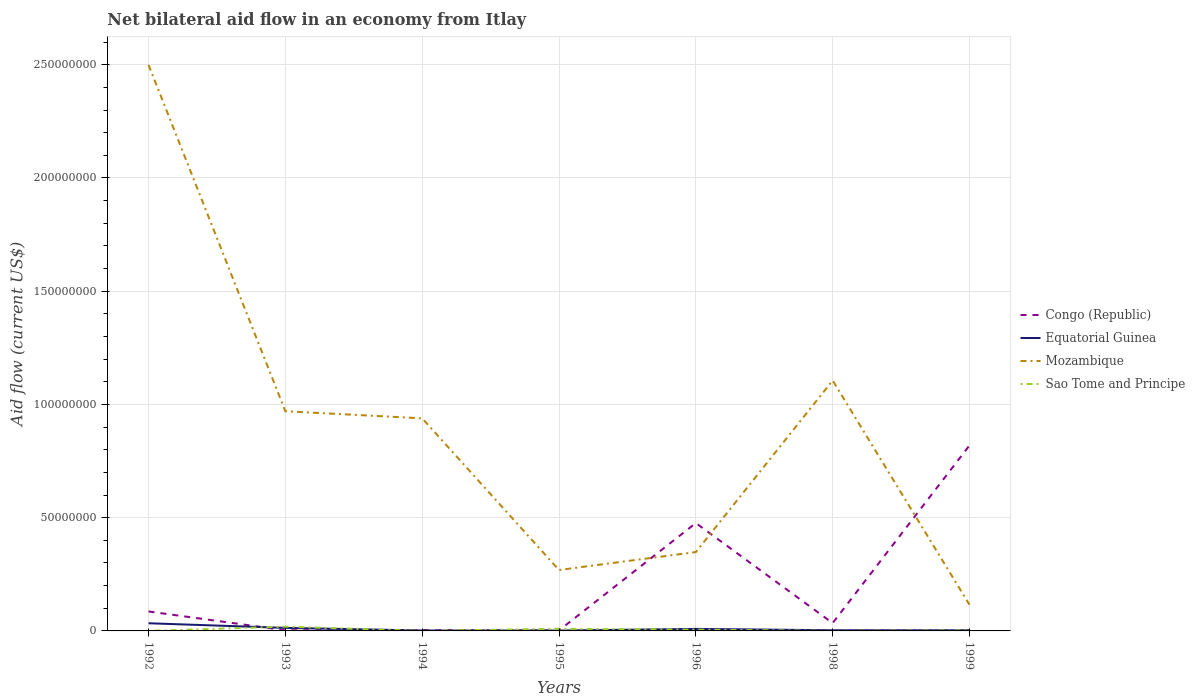Does the line corresponding to Equatorial Guinea intersect with the line corresponding to Sao Tome and Principe?
Keep it short and to the point. Yes. Is the number of lines equal to the number of legend labels?
Make the answer very short. Yes. Across all years, what is the maximum net bilateral aid flow in Mozambique?
Provide a short and direct response. 1.16e+07. What is the total net bilateral aid flow in Equatorial Guinea in the graph?
Offer a terse response. 4.50e+05. What is the difference between the highest and the second highest net bilateral aid flow in Equatorial Guinea?
Keep it short and to the point. 3.23e+06. How many lines are there?
Offer a very short reply. 4. How many years are there in the graph?
Offer a terse response. 7. What is the difference between two consecutive major ticks on the Y-axis?
Provide a succinct answer. 5.00e+07. Are the values on the major ticks of Y-axis written in scientific E-notation?
Your answer should be very brief. No. Does the graph contain any zero values?
Your answer should be compact. No. Does the graph contain grids?
Keep it short and to the point. Yes. How are the legend labels stacked?
Keep it short and to the point. Vertical. What is the title of the graph?
Give a very brief answer. Net bilateral aid flow in an economy from Itlay. Does "United Kingdom" appear as one of the legend labels in the graph?
Your response must be concise. No. What is the label or title of the X-axis?
Provide a short and direct response. Years. What is the label or title of the Y-axis?
Offer a terse response. Aid flow (current US$). What is the Aid flow (current US$) in Congo (Republic) in 1992?
Ensure brevity in your answer.  8.59e+06. What is the Aid flow (current US$) in Equatorial Guinea in 1992?
Make the answer very short. 3.39e+06. What is the Aid flow (current US$) of Mozambique in 1992?
Provide a succinct answer. 2.50e+08. What is the Aid flow (current US$) of Sao Tome and Principe in 1992?
Make the answer very short. 10000. What is the Aid flow (current US$) in Equatorial Guinea in 1993?
Your answer should be very brief. 1.34e+06. What is the Aid flow (current US$) in Mozambique in 1993?
Provide a short and direct response. 9.70e+07. What is the Aid flow (current US$) of Sao Tome and Principe in 1993?
Offer a terse response. 1.89e+06. What is the Aid flow (current US$) of Mozambique in 1994?
Give a very brief answer. 9.39e+07. What is the Aid flow (current US$) in Sao Tome and Principe in 1994?
Give a very brief answer. 10000. What is the Aid flow (current US$) of Equatorial Guinea in 1995?
Offer a terse response. 1.60e+05. What is the Aid flow (current US$) in Mozambique in 1995?
Make the answer very short. 2.69e+07. What is the Aid flow (current US$) in Sao Tome and Principe in 1995?
Offer a very short reply. 9.40e+05. What is the Aid flow (current US$) in Congo (Republic) in 1996?
Your answer should be compact. 4.76e+07. What is the Aid flow (current US$) of Equatorial Guinea in 1996?
Provide a short and direct response. 8.90e+05. What is the Aid flow (current US$) in Mozambique in 1996?
Your answer should be compact. 3.48e+07. What is the Aid flow (current US$) of Sao Tome and Principe in 1996?
Provide a short and direct response. 5.70e+05. What is the Aid flow (current US$) in Congo (Republic) in 1998?
Offer a very short reply. 3.46e+06. What is the Aid flow (current US$) of Mozambique in 1998?
Your answer should be very brief. 1.11e+08. What is the Aid flow (current US$) of Congo (Republic) in 1999?
Make the answer very short. 8.19e+07. What is the Aid flow (current US$) of Mozambique in 1999?
Your answer should be very brief. 1.16e+07. Across all years, what is the maximum Aid flow (current US$) of Congo (Republic)?
Offer a very short reply. 8.19e+07. Across all years, what is the maximum Aid flow (current US$) in Equatorial Guinea?
Your response must be concise. 3.39e+06. Across all years, what is the maximum Aid flow (current US$) in Mozambique?
Your answer should be compact. 2.50e+08. Across all years, what is the maximum Aid flow (current US$) of Sao Tome and Principe?
Give a very brief answer. 1.89e+06. Across all years, what is the minimum Aid flow (current US$) in Congo (Republic)?
Give a very brief answer. 2.30e+05. Across all years, what is the minimum Aid flow (current US$) in Equatorial Guinea?
Keep it short and to the point. 1.60e+05. Across all years, what is the minimum Aid flow (current US$) in Mozambique?
Ensure brevity in your answer.  1.16e+07. What is the total Aid flow (current US$) of Congo (Republic) in the graph?
Provide a succinct answer. 1.42e+08. What is the total Aid flow (current US$) of Equatorial Guinea in the graph?
Ensure brevity in your answer.  6.57e+06. What is the total Aid flow (current US$) of Mozambique in the graph?
Give a very brief answer. 6.25e+08. What is the total Aid flow (current US$) of Sao Tome and Principe in the graph?
Provide a short and direct response. 3.66e+06. What is the difference between the Aid flow (current US$) in Congo (Republic) in 1992 and that in 1993?
Make the answer very short. 8.31e+06. What is the difference between the Aid flow (current US$) of Equatorial Guinea in 1992 and that in 1993?
Your answer should be compact. 2.05e+06. What is the difference between the Aid flow (current US$) of Mozambique in 1992 and that in 1993?
Provide a succinct answer. 1.53e+08. What is the difference between the Aid flow (current US$) of Sao Tome and Principe in 1992 and that in 1993?
Ensure brevity in your answer.  -1.88e+06. What is the difference between the Aid flow (current US$) of Congo (Republic) in 1992 and that in 1994?
Offer a terse response. 8.26e+06. What is the difference between the Aid flow (current US$) of Equatorial Guinea in 1992 and that in 1994?
Keep it short and to the point. 3.20e+06. What is the difference between the Aid flow (current US$) in Mozambique in 1992 and that in 1994?
Your answer should be very brief. 1.56e+08. What is the difference between the Aid flow (current US$) in Congo (Republic) in 1992 and that in 1995?
Offer a very short reply. 8.36e+06. What is the difference between the Aid flow (current US$) in Equatorial Guinea in 1992 and that in 1995?
Keep it short and to the point. 3.23e+06. What is the difference between the Aid flow (current US$) of Mozambique in 1992 and that in 1995?
Give a very brief answer. 2.23e+08. What is the difference between the Aid flow (current US$) in Sao Tome and Principe in 1992 and that in 1995?
Your answer should be compact. -9.30e+05. What is the difference between the Aid flow (current US$) of Congo (Republic) in 1992 and that in 1996?
Provide a succinct answer. -3.90e+07. What is the difference between the Aid flow (current US$) of Equatorial Guinea in 1992 and that in 1996?
Provide a short and direct response. 2.50e+06. What is the difference between the Aid flow (current US$) in Mozambique in 1992 and that in 1996?
Your response must be concise. 2.15e+08. What is the difference between the Aid flow (current US$) of Sao Tome and Principe in 1992 and that in 1996?
Provide a succinct answer. -5.60e+05. What is the difference between the Aid flow (current US$) in Congo (Republic) in 1992 and that in 1998?
Offer a terse response. 5.13e+06. What is the difference between the Aid flow (current US$) of Equatorial Guinea in 1992 and that in 1998?
Your answer should be very brief. 3.09e+06. What is the difference between the Aid flow (current US$) of Mozambique in 1992 and that in 1998?
Provide a succinct answer. 1.39e+08. What is the difference between the Aid flow (current US$) in Congo (Republic) in 1992 and that in 1999?
Give a very brief answer. -7.33e+07. What is the difference between the Aid flow (current US$) in Equatorial Guinea in 1992 and that in 1999?
Offer a very short reply. 3.09e+06. What is the difference between the Aid flow (current US$) in Mozambique in 1992 and that in 1999?
Provide a short and direct response. 2.38e+08. What is the difference between the Aid flow (current US$) in Congo (Republic) in 1993 and that in 1994?
Provide a short and direct response. -5.00e+04. What is the difference between the Aid flow (current US$) of Equatorial Guinea in 1993 and that in 1994?
Offer a terse response. 1.15e+06. What is the difference between the Aid flow (current US$) of Mozambique in 1993 and that in 1994?
Keep it short and to the point. 3.13e+06. What is the difference between the Aid flow (current US$) of Sao Tome and Principe in 1993 and that in 1994?
Keep it short and to the point. 1.88e+06. What is the difference between the Aid flow (current US$) of Congo (Republic) in 1993 and that in 1995?
Provide a short and direct response. 5.00e+04. What is the difference between the Aid flow (current US$) in Equatorial Guinea in 1993 and that in 1995?
Offer a terse response. 1.18e+06. What is the difference between the Aid flow (current US$) in Mozambique in 1993 and that in 1995?
Keep it short and to the point. 7.01e+07. What is the difference between the Aid flow (current US$) in Sao Tome and Principe in 1993 and that in 1995?
Offer a terse response. 9.50e+05. What is the difference between the Aid flow (current US$) in Congo (Republic) in 1993 and that in 1996?
Make the answer very short. -4.74e+07. What is the difference between the Aid flow (current US$) of Equatorial Guinea in 1993 and that in 1996?
Ensure brevity in your answer.  4.50e+05. What is the difference between the Aid flow (current US$) of Mozambique in 1993 and that in 1996?
Your answer should be compact. 6.22e+07. What is the difference between the Aid flow (current US$) of Sao Tome and Principe in 1993 and that in 1996?
Provide a succinct answer. 1.32e+06. What is the difference between the Aid flow (current US$) of Congo (Republic) in 1993 and that in 1998?
Offer a terse response. -3.18e+06. What is the difference between the Aid flow (current US$) in Equatorial Guinea in 1993 and that in 1998?
Your response must be concise. 1.04e+06. What is the difference between the Aid flow (current US$) of Mozambique in 1993 and that in 1998?
Make the answer very short. -1.36e+07. What is the difference between the Aid flow (current US$) in Sao Tome and Principe in 1993 and that in 1998?
Offer a terse response. 1.87e+06. What is the difference between the Aid flow (current US$) in Congo (Republic) in 1993 and that in 1999?
Give a very brief answer. -8.16e+07. What is the difference between the Aid flow (current US$) of Equatorial Guinea in 1993 and that in 1999?
Your answer should be very brief. 1.04e+06. What is the difference between the Aid flow (current US$) of Mozambique in 1993 and that in 1999?
Offer a terse response. 8.54e+07. What is the difference between the Aid flow (current US$) of Sao Tome and Principe in 1993 and that in 1999?
Give a very brief answer. 1.67e+06. What is the difference between the Aid flow (current US$) of Congo (Republic) in 1994 and that in 1995?
Ensure brevity in your answer.  1.00e+05. What is the difference between the Aid flow (current US$) of Equatorial Guinea in 1994 and that in 1995?
Keep it short and to the point. 3.00e+04. What is the difference between the Aid flow (current US$) in Mozambique in 1994 and that in 1995?
Make the answer very short. 6.70e+07. What is the difference between the Aid flow (current US$) of Sao Tome and Principe in 1994 and that in 1995?
Your response must be concise. -9.30e+05. What is the difference between the Aid flow (current US$) of Congo (Republic) in 1994 and that in 1996?
Keep it short and to the point. -4.73e+07. What is the difference between the Aid flow (current US$) of Equatorial Guinea in 1994 and that in 1996?
Offer a terse response. -7.00e+05. What is the difference between the Aid flow (current US$) in Mozambique in 1994 and that in 1996?
Give a very brief answer. 5.91e+07. What is the difference between the Aid flow (current US$) of Sao Tome and Principe in 1994 and that in 1996?
Offer a terse response. -5.60e+05. What is the difference between the Aid flow (current US$) in Congo (Republic) in 1994 and that in 1998?
Offer a very short reply. -3.13e+06. What is the difference between the Aid flow (current US$) in Equatorial Guinea in 1994 and that in 1998?
Keep it short and to the point. -1.10e+05. What is the difference between the Aid flow (current US$) in Mozambique in 1994 and that in 1998?
Offer a very short reply. -1.67e+07. What is the difference between the Aid flow (current US$) of Sao Tome and Principe in 1994 and that in 1998?
Provide a succinct answer. -10000. What is the difference between the Aid flow (current US$) of Congo (Republic) in 1994 and that in 1999?
Give a very brief answer. -8.16e+07. What is the difference between the Aid flow (current US$) of Mozambique in 1994 and that in 1999?
Offer a very short reply. 8.23e+07. What is the difference between the Aid flow (current US$) of Congo (Republic) in 1995 and that in 1996?
Make the answer very short. -4.74e+07. What is the difference between the Aid flow (current US$) of Equatorial Guinea in 1995 and that in 1996?
Give a very brief answer. -7.30e+05. What is the difference between the Aid flow (current US$) in Mozambique in 1995 and that in 1996?
Make the answer very short. -7.91e+06. What is the difference between the Aid flow (current US$) of Congo (Republic) in 1995 and that in 1998?
Give a very brief answer. -3.23e+06. What is the difference between the Aid flow (current US$) in Mozambique in 1995 and that in 1998?
Provide a succinct answer. -8.37e+07. What is the difference between the Aid flow (current US$) of Sao Tome and Principe in 1995 and that in 1998?
Provide a short and direct response. 9.20e+05. What is the difference between the Aid flow (current US$) in Congo (Republic) in 1995 and that in 1999?
Provide a short and direct response. -8.17e+07. What is the difference between the Aid flow (current US$) in Mozambique in 1995 and that in 1999?
Keep it short and to the point. 1.53e+07. What is the difference between the Aid flow (current US$) of Sao Tome and Principe in 1995 and that in 1999?
Your answer should be very brief. 7.20e+05. What is the difference between the Aid flow (current US$) of Congo (Republic) in 1996 and that in 1998?
Your answer should be compact. 4.42e+07. What is the difference between the Aid flow (current US$) of Equatorial Guinea in 1996 and that in 1998?
Keep it short and to the point. 5.90e+05. What is the difference between the Aid flow (current US$) of Mozambique in 1996 and that in 1998?
Your answer should be very brief. -7.58e+07. What is the difference between the Aid flow (current US$) in Sao Tome and Principe in 1996 and that in 1998?
Offer a very short reply. 5.50e+05. What is the difference between the Aid flow (current US$) of Congo (Republic) in 1996 and that in 1999?
Provide a short and direct response. -3.43e+07. What is the difference between the Aid flow (current US$) in Equatorial Guinea in 1996 and that in 1999?
Keep it short and to the point. 5.90e+05. What is the difference between the Aid flow (current US$) in Mozambique in 1996 and that in 1999?
Offer a terse response. 2.32e+07. What is the difference between the Aid flow (current US$) of Sao Tome and Principe in 1996 and that in 1999?
Make the answer very short. 3.50e+05. What is the difference between the Aid flow (current US$) of Congo (Republic) in 1998 and that in 1999?
Offer a terse response. -7.84e+07. What is the difference between the Aid flow (current US$) in Equatorial Guinea in 1998 and that in 1999?
Your answer should be very brief. 0. What is the difference between the Aid flow (current US$) in Mozambique in 1998 and that in 1999?
Provide a succinct answer. 9.90e+07. What is the difference between the Aid flow (current US$) in Congo (Republic) in 1992 and the Aid flow (current US$) in Equatorial Guinea in 1993?
Provide a succinct answer. 7.25e+06. What is the difference between the Aid flow (current US$) of Congo (Republic) in 1992 and the Aid flow (current US$) of Mozambique in 1993?
Ensure brevity in your answer.  -8.84e+07. What is the difference between the Aid flow (current US$) of Congo (Republic) in 1992 and the Aid flow (current US$) of Sao Tome and Principe in 1993?
Provide a succinct answer. 6.70e+06. What is the difference between the Aid flow (current US$) in Equatorial Guinea in 1992 and the Aid flow (current US$) in Mozambique in 1993?
Your answer should be compact. -9.36e+07. What is the difference between the Aid flow (current US$) in Equatorial Guinea in 1992 and the Aid flow (current US$) in Sao Tome and Principe in 1993?
Your answer should be very brief. 1.50e+06. What is the difference between the Aid flow (current US$) of Mozambique in 1992 and the Aid flow (current US$) of Sao Tome and Principe in 1993?
Offer a very short reply. 2.48e+08. What is the difference between the Aid flow (current US$) of Congo (Republic) in 1992 and the Aid flow (current US$) of Equatorial Guinea in 1994?
Provide a succinct answer. 8.40e+06. What is the difference between the Aid flow (current US$) in Congo (Republic) in 1992 and the Aid flow (current US$) in Mozambique in 1994?
Give a very brief answer. -8.53e+07. What is the difference between the Aid flow (current US$) of Congo (Republic) in 1992 and the Aid flow (current US$) of Sao Tome and Principe in 1994?
Ensure brevity in your answer.  8.58e+06. What is the difference between the Aid flow (current US$) in Equatorial Guinea in 1992 and the Aid flow (current US$) in Mozambique in 1994?
Your response must be concise. -9.05e+07. What is the difference between the Aid flow (current US$) in Equatorial Guinea in 1992 and the Aid flow (current US$) in Sao Tome and Principe in 1994?
Provide a short and direct response. 3.38e+06. What is the difference between the Aid flow (current US$) of Mozambique in 1992 and the Aid flow (current US$) of Sao Tome and Principe in 1994?
Provide a short and direct response. 2.50e+08. What is the difference between the Aid flow (current US$) of Congo (Republic) in 1992 and the Aid flow (current US$) of Equatorial Guinea in 1995?
Keep it short and to the point. 8.43e+06. What is the difference between the Aid flow (current US$) in Congo (Republic) in 1992 and the Aid flow (current US$) in Mozambique in 1995?
Your response must be concise. -1.83e+07. What is the difference between the Aid flow (current US$) of Congo (Republic) in 1992 and the Aid flow (current US$) of Sao Tome and Principe in 1995?
Your answer should be compact. 7.65e+06. What is the difference between the Aid flow (current US$) in Equatorial Guinea in 1992 and the Aid flow (current US$) in Mozambique in 1995?
Your response must be concise. -2.35e+07. What is the difference between the Aid flow (current US$) in Equatorial Guinea in 1992 and the Aid flow (current US$) in Sao Tome and Principe in 1995?
Make the answer very short. 2.45e+06. What is the difference between the Aid flow (current US$) in Mozambique in 1992 and the Aid flow (current US$) in Sao Tome and Principe in 1995?
Offer a very short reply. 2.49e+08. What is the difference between the Aid flow (current US$) of Congo (Republic) in 1992 and the Aid flow (current US$) of Equatorial Guinea in 1996?
Your response must be concise. 7.70e+06. What is the difference between the Aid flow (current US$) in Congo (Republic) in 1992 and the Aid flow (current US$) in Mozambique in 1996?
Provide a short and direct response. -2.62e+07. What is the difference between the Aid flow (current US$) of Congo (Republic) in 1992 and the Aid flow (current US$) of Sao Tome and Principe in 1996?
Your response must be concise. 8.02e+06. What is the difference between the Aid flow (current US$) in Equatorial Guinea in 1992 and the Aid flow (current US$) in Mozambique in 1996?
Ensure brevity in your answer.  -3.14e+07. What is the difference between the Aid flow (current US$) of Equatorial Guinea in 1992 and the Aid flow (current US$) of Sao Tome and Principe in 1996?
Your answer should be very brief. 2.82e+06. What is the difference between the Aid flow (current US$) of Mozambique in 1992 and the Aid flow (current US$) of Sao Tome and Principe in 1996?
Keep it short and to the point. 2.49e+08. What is the difference between the Aid flow (current US$) of Congo (Republic) in 1992 and the Aid flow (current US$) of Equatorial Guinea in 1998?
Your answer should be compact. 8.29e+06. What is the difference between the Aid flow (current US$) in Congo (Republic) in 1992 and the Aid flow (current US$) in Mozambique in 1998?
Your answer should be compact. -1.02e+08. What is the difference between the Aid flow (current US$) of Congo (Republic) in 1992 and the Aid flow (current US$) of Sao Tome and Principe in 1998?
Ensure brevity in your answer.  8.57e+06. What is the difference between the Aid flow (current US$) of Equatorial Guinea in 1992 and the Aid flow (current US$) of Mozambique in 1998?
Your answer should be compact. -1.07e+08. What is the difference between the Aid flow (current US$) in Equatorial Guinea in 1992 and the Aid flow (current US$) in Sao Tome and Principe in 1998?
Offer a terse response. 3.37e+06. What is the difference between the Aid flow (current US$) of Mozambique in 1992 and the Aid flow (current US$) of Sao Tome and Principe in 1998?
Provide a short and direct response. 2.50e+08. What is the difference between the Aid flow (current US$) in Congo (Republic) in 1992 and the Aid flow (current US$) in Equatorial Guinea in 1999?
Your answer should be very brief. 8.29e+06. What is the difference between the Aid flow (current US$) of Congo (Republic) in 1992 and the Aid flow (current US$) of Mozambique in 1999?
Your answer should be very brief. -2.97e+06. What is the difference between the Aid flow (current US$) of Congo (Republic) in 1992 and the Aid flow (current US$) of Sao Tome and Principe in 1999?
Your response must be concise. 8.37e+06. What is the difference between the Aid flow (current US$) in Equatorial Guinea in 1992 and the Aid flow (current US$) in Mozambique in 1999?
Your answer should be compact. -8.17e+06. What is the difference between the Aid flow (current US$) in Equatorial Guinea in 1992 and the Aid flow (current US$) in Sao Tome and Principe in 1999?
Keep it short and to the point. 3.17e+06. What is the difference between the Aid flow (current US$) in Mozambique in 1992 and the Aid flow (current US$) in Sao Tome and Principe in 1999?
Provide a succinct answer. 2.50e+08. What is the difference between the Aid flow (current US$) of Congo (Republic) in 1993 and the Aid flow (current US$) of Mozambique in 1994?
Provide a succinct answer. -9.36e+07. What is the difference between the Aid flow (current US$) in Equatorial Guinea in 1993 and the Aid flow (current US$) in Mozambique in 1994?
Your response must be concise. -9.25e+07. What is the difference between the Aid flow (current US$) in Equatorial Guinea in 1993 and the Aid flow (current US$) in Sao Tome and Principe in 1994?
Ensure brevity in your answer.  1.33e+06. What is the difference between the Aid flow (current US$) of Mozambique in 1993 and the Aid flow (current US$) of Sao Tome and Principe in 1994?
Your answer should be compact. 9.70e+07. What is the difference between the Aid flow (current US$) in Congo (Republic) in 1993 and the Aid flow (current US$) in Equatorial Guinea in 1995?
Ensure brevity in your answer.  1.20e+05. What is the difference between the Aid flow (current US$) of Congo (Republic) in 1993 and the Aid flow (current US$) of Mozambique in 1995?
Your response must be concise. -2.66e+07. What is the difference between the Aid flow (current US$) in Congo (Republic) in 1993 and the Aid flow (current US$) in Sao Tome and Principe in 1995?
Ensure brevity in your answer.  -6.60e+05. What is the difference between the Aid flow (current US$) of Equatorial Guinea in 1993 and the Aid flow (current US$) of Mozambique in 1995?
Offer a terse response. -2.56e+07. What is the difference between the Aid flow (current US$) in Equatorial Guinea in 1993 and the Aid flow (current US$) in Sao Tome and Principe in 1995?
Give a very brief answer. 4.00e+05. What is the difference between the Aid flow (current US$) of Mozambique in 1993 and the Aid flow (current US$) of Sao Tome and Principe in 1995?
Your answer should be very brief. 9.61e+07. What is the difference between the Aid flow (current US$) in Congo (Republic) in 1993 and the Aid flow (current US$) in Equatorial Guinea in 1996?
Offer a terse response. -6.10e+05. What is the difference between the Aid flow (current US$) of Congo (Republic) in 1993 and the Aid flow (current US$) of Mozambique in 1996?
Your response must be concise. -3.45e+07. What is the difference between the Aid flow (current US$) in Congo (Republic) in 1993 and the Aid flow (current US$) in Sao Tome and Principe in 1996?
Keep it short and to the point. -2.90e+05. What is the difference between the Aid flow (current US$) of Equatorial Guinea in 1993 and the Aid flow (current US$) of Mozambique in 1996?
Provide a succinct answer. -3.35e+07. What is the difference between the Aid flow (current US$) in Equatorial Guinea in 1993 and the Aid flow (current US$) in Sao Tome and Principe in 1996?
Keep it short and to the point. 7.70e+05. What is the difference between the Aid flow (current US$) of Mozambique in 1993 and the Aid flow (current US$) of Sao Tome and Principe in 1996?
Give a very brief answer. 9.64e+07. What is the difference between the Aid flow (current US$) of Congo (Republic) in 1993 and the Aid flow (current US$) of Mozambique in 1998?
Your response must be concise. -1.10e+08. What is the difference between the Aid flow (current US$) in Equatorial Guinea in 1993 and the Aid flow (current US$) in Mozambique in 1998?
Give a very brief answer. -1.09e+08. What is the difference between the Aid flow (current US$) of Equatorial Guinea in 1993 and the Aid flow (current US$) of Sao Tome and Principe in 1998?
Give a very brief answer. 1.32e+06. What is the difference between the Aid flow (current US$) in Mozambique in 1993 and the Aid flow (current US$) in Sao Tome and Principe in 1998?
Make the answer very short. 9.70e+07. What is the difference between the Aid flow (current US$) in Congo (Republic) in 1993 and the Aid flow (current US$) in Mozambique in 1999?
Ensure brevity in your answer.  -1.13e+07. What is the difference between the Aid flow (current US$) in Congo (Republic) in 1993 and the Aid flow (current US$) in Sao Tome and Principe in 1999?
Offer a very short reply. 6.00e+04. What is the difference between the Aid flow (current US$) in Equatorial Guinea in 1993 and the Aid flow (current US$) in Mozambique in 1999?
Provide a succinct answer. -1.02e+07. What is the difference between the Aid flow (current US$) of Equatorial Guinea in 1993 and the Aid flow (current US$) of Sao Tome and Principe in 1999?
Keep it short and to the point. 1.12e+06. What is the difference between the Aid flow (current US$) in Mozambique in 1993 and the Aid flow (current US$) in Sao Tome and Principe in 1999?
Keep it short and to the point. 9.68e+07. What is the difference between the Aid flow (current US$) of Congo (Republic) in 1994 and the Aid flow (current US$) of Equatorial Guinea in 1995?
Your answer should be very brief. 1.70e+05. What is the difference between the Aid flow (current US$) of Congo (Republic) in 1994 and the Aid flow (current US$) of Mozambique in 1995?
Your response must be concise. -2.66e+07. What is the difference between the Aid flow (current US$) in Congo (Republic) in 1994 and the Aid flow (current US$) in Sao Tome and Principe in 1995?
Give a very brief answer. -6.10e+05. What is the difference between the Aid flow (current US$) in Equatorial Guinea in 1994 and the Aid flow (current US$) in Mozambique in 1995?
Make the answer very short. -2.67e+07. What is the difference between the Aid flow (current US$) of Equatorial Guinea in 1994 and the Aid flow (current US$) of Sao Tome and Principe in 1995?
Offer a very short reply. -7.50e+05. What is the difference between the Aid flow (current US$) of Mozambique in 1994 and the Aid flow (current US$) of Sao Tome and Principe in 1995?
Make the answer very short. 9.29e+07. What is the difference between the Aid flow (current US$) in Congo (Republic) in 1994 and the Aid flow (current US$) in Equatorial Guinea in 1996?
Your response must be concise. -5.60e+05. What is the difference between the Aid flow (current US$) in Congo (Republic) in 1994 and the Aid flow (current US$) in Mozambique in 1996?
Provide a succinct answer. -3.45e+07. What is the difference between the Aid flow (current US$) of Congo (Republic) in 1994 and the Aid flow (current US$) of Sao Tome and Principe in 1996?
Offer a terse response. -2.40e+05. What is the difference between the Aid flow (current US$) in Equatorial Guinea in 1994 and the Aid flow (current US$) in Mozambique in 1996?
Keep it short and to the point. -3.46e+07. What is the difference between the Aid flow (current US$) of Equatorial Guinea in 1994 and the Aid flow (current US$) of Sao Tome and Principe in 1996?
Make the answer very short. -3.80e+05. What is the difference between the Aid flow (current US$) in Mozambique in 1994 and the Aid flow (current US$) in Sao Tome and Principe in 1996?
Your answer should be compact. 9.33e+07. What is the difference between the Aid flow (current US$) in Congo (Republic) in 1994 and the Aid flow (current US$) in Equatorial Guinea in 1998?
Offer a very short reply. 3.00e+04. What is the difference between the Aid flow (current US$) in Congo (Republic) in 1994 and the Aid flow (current US$) in Mozambique in 1998?
Offer a terse response. -1.10e+08. What is the difference between the Aid flow (current US$) of Equatorial Guinea in 1994 and the Aid flow (current US$) of Mozambique in 1998?
Your answer should be compact. -1.10e+08. What is the difference between the Aid flow (current US$) of Equatorial Guinea in 1994 and the Aid flow (current US$) of Sao Tome and Principe in 1998?
Ensure brevity in your answer.  1.70e+05. What is the difference between the Aid flow (current US$) of Mozambique in 1994 and the Aid flow (current US$) of Sao Tome and Principe in 1998?
Keep it short and to the point. 9.38e+07. What is the difference between the Aid flow (current US$) of Congo (Republic) in 1994 and the Aid flow (current US$) of Equatorial Guinea in 1999?
Your answer should be very brief. 3.00e+04. What is the difference between the Aid flow (current US$) of Congo (Republic) in 1994 and the Aid flow (current US$) of Mozambique in 1999?
Ensure brevity in your answer.  -1.12e+07. What is the difference between the Aid flow (current US$) in Congo (Republic) in 1994 and the Aid flow (current US$) in Sao Tome and Principe in 1999?
Your answer should be very brief. 1.10e+05. What is the difference between the Aid flow (current US$) of Equatorial Guinea in 1994 and the Aid flow (current US$) of Mozambique in 1999?
Provide a succinct answer. -1.14e+07. What is the difference between the Aid flow (current US$) of Mozambique in 1994 and the Aid flow (current US$) of Sao Tome and Principe in 1999?
Give a very brief answer. 9.36e+07. What is the difference between the Aid flow (current US$) of Congo (Republic) in 1995 and the Aid flow (current US$) of Equatorial Guinea in 1996?
Provide a succinct answer. -6.60e+05. What is the difference between the Aid flow (current US$) of Congo (Republic) in 1995 and the Aid flow (current US$) of Mozambique in 1996?
Your answer should be compact. -3.46e+07. What is the difference between the Aid flow (current US$) in Equatorial Guinea in 1995 and the Aid flow (current US$) in Mozambique in 1996?
Your response must be concise. -3.46e+07. What is the difference between the Aid flow (current US$) of Equatorial Guinea in 1995 and the Aid flow (current US$) of Sao Tome and Principe in 1996?
Offer a terse response. -4.10e+05. What is the difference between the Aid flow (current US$) of Mozambique in 1995 and the Aid flow (current US$) of Sao Tome and Principe in 1996?
Your response must be concise. 2.63e+07. What is the difference between the Aid flow (current US$) of Congo (Republic) in 1995 and the Aid flow (current US$) of Equatorial Guinea in 1998?
Give a very brief answer. -7.00e+04. What is the difference between the Aid flow (current US$) in Congo (Republic) in 1995 and the Aid flow (current US$) in Mozambique in 1998?
Ensure brevity in your answer.  -1.10e+08. What is the difference between the Aid flow (current US$) of Congo (Republic) in 1995 and the Aid flow (current US$) of Sao Tome and Principe in 1998?
Your answer should be compact. 2.10e+05. What is the difference between the Aid flow (current US$) of Equatorial Guinea in 1995 and the Aid flow (current US$) of Mozambique in 1998?
Your answer should be compact. -1.10e+08. What is the difference between the Aid flow (current US$) in Mozambique in 1995 and the Aid flow (current US$) in Sao Tome and Principe in 1998?
Provide a short and direct response. 2.69e+07. What is the difference between the Aid flow (current US$) of Congo (Republic) in 1995 and the Aid flow (current US$) of Mozambique in 1999?
Keep it short and to the point. -1.13e+07. What is the difference between the Aid flow (current US$) of Congo (Republic) in 1995 and the Aid flow (current US$) of Sao Tome and Principe in 1999?
Ensure brevity in your answer.  10000. What is the difference between the Aid flow (current US$) in Equatorial Guinea in 1995 and the Aid flow (current US$) in Mozambique in 1999?
Make the answer very short. -1.14e+07. What is the difference between the Aid flow (current US$) in Equatorial Guinea in 1995 and the Aid flow (current US$) in Sao Tome and Principe in 1999?
Keep it short and to the point. -6.00e+04. What is the difference between the Aid flow (current US$) of Mozambique in 1995 and the Aid flow (current US$) of Sao Tome and Principe in 1999?
Ensure brevity in your answer.  2.67e+07. What is the difference between the Aid flow (current US$) of Congo (Republic) in 1996 and the Aid flow (current US$) of Equatorial Guinea in 1998?
Provide a short and direct response. 4.73e+07. What is the difference between the Aid flow (current US$) of Congo (Republic) in 1996 and the Aid flow (current US$) of Mozambique in 1998?
Give a very brief answer. -6.29e+07. What is the difference between the Aid flow (current US$) of Congo (Republic) in 1996 and the Aid flow (current US$) of Sao Tome and Principe in 1998?
Offer a very short reply. 4.76e+07. What is the difference between the Aid flow (current US$) in Equatorial Guinea in 1996 and the Aid flow (current US$) in Mozambique in 1998?
Offer a very short reply. -1.10e+08. What is the difference between the Aid flow (current US$) in Equatorial Guinea in 1996 and the Aid flow (current US$) in Sao Tome and Principe in 1998?
Your answer should be very brief. 8.70e+05. What is the difference between the Aid flow (current US$) in Mozambique in 1996 and the Aid flow (current US$) in Sao Tome and Principe in 1998?
Offer a very short reply. 3.48e+07. What is the difference between the Aid flow (current US$) of Congo (Republic) in 1996 and the Aid flow (current US$) of Equatorial Guinea in 1999?
Your answer should be very brief. 4.73e+07. What is the difference between the Aid flow (current US$) of Congo (Republic) in 1996 and the Aid flow (current US$) of Mozambique in 1999?
Provide a succinct answer. 3.61e+07. What is the difference between the Aid flow (current US$) in Congo (Republic) in 1996 and the Aid flow (current US$) in Sao Tome and Principe in 1999?
Your answer should be very brief. 4.74e+07. What is the difference between the Aid flow (current US$) of Equatorial Guinea in 1996 and the Aid flow (current US$) of Mozambique in 1999?
Offer a very short reply. -1.07e+07. What is the difference between the Aid flow (current US$) in Equatorial Guinea in 1996 and the Aid flow (current US$) in Sao Tome and Principe in 1999?
Offer a very short reply. 6.70e+05. What is the difference between the Aid flow (current US$) in Mozambique in 1996 and the Aid flow (current US$) in Sao Tome and Principe in 1999?
Keep it short and to the point. 3.46e+07. What is the difference between the Aid flow (current US$) in Congo (Republic) in 1998 and the Aid flow (current US$) in Equatorial Guinea in 1999?
Offer a terse response. 3.16e+06. What is the difference between the Aid flow (current US$) in Congo (Republic) in 1998 and the Aid flow (current US$) in Mozambique in 1999?
Provide a short and direct response. -8.10e+06. What is the difference between the Aid flow (current US$) in Congo (Republic) in 1998 and the Aid flow (current US$) in Sao Tome and Principe in 1999?
Ensure brevity in your answer.  3.24e+06. What is the difference between the Aid flow (current US$) in Equatorial Guinea in 1998 and the Aid flow (current US$) in Mozambique in 1999?
Offer a terse response. -1.13e+07. What is the difference between the Aid flow (current US$) of Mozambique in 1998 and the Aid flow (current US$) of Sao Tome and Principe in 1999?
Provide a succinct answer. 1.10e+08. What is the average Aid flow (current US$) of Congo (Republic) per year?
Your answer should be very brief. 2.03e+07. What is the average Aid flow (current US$) in Equatorial Guinea per year?
Your response must be concise. 9.39e+05. What is the average Aid flow (current US$) of Mozambique per year?
Offer a very short reply. 8.92e+07. What is the average Aid flow (current US$) in Sao Tome and Principe per year?
Ensure brevity in your answer.  5.23e+05. In the year 1992, what is the difference between the Aid flow (current US$) of Congo (Republic) and Aid flow (current US$) of Equatorial Guinea?
Your answer should be compact. 5.20e+06. In the year 1992, what is the difference between the Aid flow (current US$) of Congo (Republic) and Aid flow (current US$) of Mozambique?
Offer a terse response. -2.41e+08. In the year 1992, what is the difference between the Aid flow (current US$) of Congo (Republic) and Aid flow (current US$) of Sao Tome and Principe?
Ensure brevity in your answer.  8.58e+06. In the year 1992, what is the difference between the Aid flow (current US$) of Equatorial Guinea and Aid flow (current US$) of Mozambique?
Offer a terse response. -2.47e+08. In the year 1992, what is the difference between the Aid flow (current US$) in Equatorial Guinea and Aid flow (current US$) in Sao Tome and Principe?
Give a very brief answer. 3.38e+06. In the year 1992, what is the difference between the Aid flow (current US$) of Mozambique and Aid flow (current US$) of Sao Tome and Principe?
Keep it short and to the point. 2.50e+08. In the year 1993, what is the difference between the Aid flow (current US$) in Congo (Republic) and Aid flow (current US$) in Equatorial Guinea?
Offer a very short reply. -1.06e+06. In the year 1993, what is the difference between the Aid flow (current US$) of Congo (Republic) and Aid flow (current US$) of Mozambique?
Your response must be concise. -9.67e+07. In the year 1993, what is the difference between the Aid flow (current US$) of Congo (Republic) and Aid flow (current US$) of Sao Tome and Principe?
Ensure brevity in your answer.  -1.61e+06. In the year 1993, what is the difference between the Aid flow (current US$) of Equatorial Guinea and Aid flow (current US$) of Mozambique?
Your answer should be very brief. -9.57e+07. In the year 1993, what is the difference between the Aid flow (current US$) of Equatorial Guinea and Aid flow (current US$) of Sao Tome and Principe?
Offer a very short reply. -5.50e+05. In the year 1993, what is the difference between the Aid flow (current US$) in Mozambique and Aid flow (current US$) in Sao Tome and Principe?
Your answer should be very brief. 9.51e+07. In the year 1994, what is the difference between the Aid flow (current US$) of Congo (Republic) and Aid flow (current US$) of Mozambique?
Give a very brief answer. -9.35e+07. In the year 1994, what is the difference between the Aid flow (current US$) in Congo (Republic) and Aid flow (current US$) in Sao Tome and Principe?
Offer a terse response. 3.20e+05. In the year 1994, what is the difference between the Aid flow (current US$) in Equatorial Guinea and Aid flow (current US$) in Mozambique?
Your answer should be compact. -9.37e+07. In the year 1994, what is the difference between the Aid flow (current US$) in Equatorial Guinea and Aid flow (current US$) in Sao Tome and Principe?
Keep it short and to the point. 1.80e+05. In the year 1994, what is the difference between the Aid flow (current US$) in Mozambique and Aid flow (current US$) in Sao Tome and Principe?
Ensure brevity in your answer.  9.39e+07. In the year 1995, what is the difference between the Aid flow (current US$) in Congo (Republic) and Aid flow (current US$) in Mozambique?
Offer a very short reply. -2.67e+07. In the year 1995, what is the difference between the Aid flow (current US$) in Congo (Republic) and Aid flow (current US$) in Sao Tome and Principe?
Make the answer very short. -7.10e+05. In the year 1995, what is the difference between the Aid flow (current US$) in Equatorial Guinea and Aid flow (current US$) in Mozambique?
Provide a succinct answer. -2.67e+07. In the year 1995, what is the difference between the Aid flow (current US$) of Equatorial Guinea and Aid flow (current US$) of Sao Tome and Principe?
Keep it short and to the point. -7.80e+05. In the year 1995, what is the difference between the Aid flow (current US$) of Mozambique and Aid flow (current US$) of Sao Tome and Principe?
Your response must be concise. 2.60e+07. In the year 1996, what is the difference between the Aid flow (current US$) in Congo (Republic) and Aid flow (current US$) in Equatorial Guinea?
Keep it short and to the point. 4.67e+07. In the year 1996, what is the difference between the Aid flow (current US$) of Congo (Republic) and Aid flow (current US$) of Mozambique?
Provide a succinct answer. 1.28e+07. In the year 1996, what is the difference between the Aid flow (current US$) in Congo (Republic) and Aid flow (current US$) in Sao Tome and Principe?
Your answer should be very brief. 4.71e+07. In the year 1996, what is the difference between the Aid flow (current US$) of Equatorial Guinea and Aid flow (current US$) of Mozambique?
Your answer should be very brief. -3.39e+07. In the year 1996, what is the difference between the Aid flow (current US$) of Mozambique and Aid flow (current US$) of Sao Tome and Principe?
Offer a very short reply. 3.42e+07. In the year 1998, what is the difference between the Aid flow (current US$) of Congo (Republic) and Aid flow (current US$) of Equatorial Guinea?
Your answer should be very brief. 3.16e+06. In the year 1998, what is the difference between the Aid flow (current US$) in Congo (Republic) and Aid flow (current US$) in Mozambique?
Offer a very short reply. -1.07e+08. In the year 1998, what is the difference between the Aid flow (current US$) in Congo (Republic) and Aid flow (current US$) in Sao Tome and Principe?
Keep it short and to the point. 3.44e+06. In the year 1998, what is the difference between the Aid flow (current US$) of Equatorial Guinea and Aid flow (current US$) of Mozambique?
Ensure brevity in your answer.  -1.10e+08. In the year 1998, what is the difference between the Aid flow (current US$) of Equatorial Guinea and Aid flow (current US$) of Sao Tome and Principe?
Your answer should be very brief. 2.80e+05. In the year 1998, what is the difference between the Aid flow (current US$) in Mozambique and Aid flow (current US$) in Sao Tome and Principe?
Provide a succinct answer. 1.11e+08. In the year 1999, what is the difference between the Aid flow (current US$) in Congo (Republic) and Aid flow (current US$) in Equatorial Guinea?
Offer a terse response. 8.16e+07. In the year 1999, what is the difference between the Aid flow (current US$) of Congo (Republic) and Aid flow (current US$) of Mozambique?
Your answer should be compact. 7.04e+07. In the year 1999, what is the difference between the Aid flow (current US$) in Congo (Republic) and Aid flow (current US$) in Sao Tome and Principe?
Your response must be concise. 8.17e+07. In the year 1999, what is the difference between the Aid flow (current US$) of Equatorial Guinea and Aid flow (current US$) of Mozambique?
Your answer should be very brief. -1.13e+07. In the year 1999, what is the difference between the Aid flow (current US$) in Equatorial Guinea and Aid flow (current US$) in Sao Tome and Principe?
Offer a very short reply. 8.00e+04. In the year 1999, what is the difference between the Aid flow (current US$) of Mozambique and Aid flow (current US$) of Sao Tome and Principe?
Ensure brevity in your answer.  1.13e+07. What is the ratio of the Aid flow (current US$) of Congo (Republic) in 1992 to that in 1993?
Your answer should be very brief. 30.68. What is the ratio of the Aid flow (current US$) in Equatorial Guinea in 1992 to that in 1993?
Offer a terse response. 2.53. What is the ratio of the Aid flow (current US$) of Mozambique in 1992 to that in 1993?
Provide a succinct answer. 2.58. What is the ratio of the Aid flow (current US$) in Sao Tome and Principe in 1992 to that in 1993?
Offer a terse response. 0.01. What is the ratio of the Aid flow (current US$) in Congo (Republic) in 1992 to that in 1994?
Offer a very short reply. 26.03. What is the ratio of the Aid flow (current US$) in Equatorial Guinea in 1992 to that in 1994?
Make the answer very short. 17.84. What is the ratio of the Aid flow (current US$) of Mozambique in 1992 to that in 1994?
Your response must be concise. 2.66. What is the ratio of the Aid flow (current US$) in Sao Tome and Principe in 1992 to that in 1994?
Your response must be concise. 1. What is the ratio of the Aid flow (current US$) in Congo (Republic) in 1992 to that in 1995?
Offer a very short reply. 37.35. What is the ratio of the Aid flow (current US$) of Equatorial Guinea in 1992 to that in 1995?
Keep it short and to the point. 21.19. What is the ratio of the Aid flow (current US$) in Mozambique in 1992 to that in 1995?
Give a very brief answer. 9.29. What is the ratio of the Aid flow (current US$) in Sao Tome and Principe in 1992 to that in 1995?
Ensure brevity in your answer.  0.01. What is the ratio of the Aid flow (current US$) in Congo (Republic) in 1992 to that in 1996?
Keep it short and to the point. 0.18. What is the ratio of the Aid flow (current US$) in Equatorial Guinea in 1992 to that in 1996?
Your response must be concise. 3.81. What is the ratio of the Aid flow (current US$) in Mozambique in 1992 to that in 1996?
Provide a short and direct response. 7.18. What is the ratio of the Aid flow (current US$) in Sao Tome and Principe in 1992 to that in 1996?
Make the answer very short. 0.02. What is the ratio of the Aid flow (current US$) of Congo (Republic) in 1992 to that in 1998?
Offer a terse response. 2.48. What is the ratio of the Aid flow (current US$) of Mozambique in 1992 to that in 1998?
Ensure brevity in your answer.  2.26. What is the ratio of the Aid flow (current US$) of Congo (Republic) in 1992 to that in 1999?
Provide a short and direct response. 0.1. What is the ratio of the Aid flow (current US$) of Mozambique in 1992 to that in 1999?
Give a very brief answer. 21.62. What is the ratio of the Aid flow (current US$) of Sao Tome and Principe in 1992 to that in 1999?
Offer a very short reply. 0.05. What is the ratio of the Aid flow (current US$) in Congo (Republic) in 1993 to that in 1994?
Keep it short and to the point. 0.85. What is the ratio of the Aid flow (current US$) in Equatorial Guinea in 1993 to that in 1994?
Make the answer very short. 7.05. What is the ratio of the Aid flow (current US$) in Mozambique in 1993 to that in 1994?
Your answer should be compact. 1.03. What is the ratio of the Aid flow (current US$) of Sao Tome and Principe in 1993 to that in 1994?
Offer a very short reply. 189. What is the ratio of the Aid flow (current US$) of Congo (Republic) in 1993 to that in 1995?
Ensure brevity in your answer.  1.22. What is the ratio of the Aid flow (current US$) in Equatorial Guinea in 1993 to that in 1995?
Make the answer very short. 8.38. What is the ratio of the Aid flow (current US$) of Mozambique in 1993 to that in 1995?
Offer a very short reply. 3.61. What is the ratio of the Aid flow (current US$) of Sao Tome and Principe in 1993 to that in 1995?
Provide a short and direct response. 2.01. What is the ratio of the Aid flow (current US$) in Congo (Republic) in 1993 to that in 1996?
Your answer should be compact. 0.01. What is the ratio of the Aid flow (current US$) in Equatorial Guinea in 1993 to that in 1996?
Make the answer very short. 1.51. What is the ratio of the Aid flow (current US$) in Mozambique in 1993 to that in 1996?
Give a very brief answer. 2.79. What is the ratio of the Aid flow (current US$) in Sao Tome and Principe in 1993 to that in 1996?
Keep it short and to the point. 3.32. What is the ratio of the Aid flow (current US$) of Congo (Republic) in 1993 to that in 1998?
Your answer should be compact. 0.08. What is the ratio of the Aid flow (current US$) in Equatorial Guinea in 1993 to that in 1998?
Provide a short and direct response. 4.47. What is the ratio of the Aid flow (current US$) in Mozambique in 1993 to that in 1998?
Make the answer very short. 0.88. What is the ratio of the Aid flow (current US$) in Sao Tome and Principe in 1993 to that in 1998?
Give a very brief answer. 94.5. What is the ratio of the Aid flow (current US$) of Congo (Republic) in 1993 to that in 1999?
Offer a very short reply. 0. What is the ratio of the Aid flow (current US$) of Equatorial Guinea in 1993 to that in 1999?
Keep it short and to the point. 4.47. What is the ratio of the Aid flow (current US$) in Mozambique in 1993 to that in 1999?
Ensure brevity in your answer.  8.39. What is the ratio of the Aid flow (current US$) of Sao Tome and Principe in 1993 to that in 1999?
Your answer should be very brief. 8.59. What is the ratio of the Aid flow (current US$) in Congo (Republic) in 1994 to that in 1995?
Make the answer very short. 1.43. What is the ratio of the Aid flow (current US$) of Equatorial Guinea in 1994 to that in 1995?
Provide a succinct answer. 1.19. What is the ratio of the Aid flow (current US$) in Mozambique in 1994 to that in 1995?
Offer a very short reply. 3.49. What is the ratio of the Aid flow (current US$) of Sao Tome and Principe in 1994 to that in 1995?
Give a very brief answer. 0.01. What is the ratio of the Aid flow (current US$) in Congo (Republic) in 1994 to that in 1996?
Your answer should be very brief. 0.01. What is the ratio of the Aid flow (current US$) in Equatorial Guinea in 1994 to that in 1996?
Keep it short and to the point. 0.21. What is the ratio of the Aid flow (current US$) in Mozambique in 1994 to that in 1996?
Offer a terse response. 2.7. What is the ratio of the Aid flow (current US$) of Sao Tome and Principe in 1994 to that in 1996?
Offer a terse response. 0.02. What is the ratio of the Aid flow (current US$) of Congo (Republic) in 1994 to that in 1998?
Give a very brief answer. 0.1. What is the ratio of the Aid flow (current US$) in Equatorial Guinea in 1994 to that in 1998?
Make the answer very short. 0.63. What is the ratio of the Aid flow (current US$) of Mozambique in 1994 to that in 1998?
Your answer should be very brief. 0.85. What is the ratio of the Aid flow (current US$) of Congo (Republic) in 1994 to that in 1999?
Ensure brevity in your answer.  0. What is the ratio of the Aid flow (current US$) in Equatorial Guinea in 1994 to that in 1999?
Your response must be concise. 0.63. What is the ratio of the Aid flow (current US$) in Mozambique in 1994 to that in 1999?
Provide a short and direct response. 8.12. What is the ratio of the Aid flow (current US$) in Sao Tome and Principe in 1994 to that in 1999?
Your answer should be very brief. 0.05. What is the ratio of the Aid flow (current US$) in Congo (Republic) in 1995 to that in 1996?
Give a very brief answer. 0. What is the ratio of the Aid flow (current US$) in Equatorial Guinea in 1995 to that in 1996?
Provide a succinct answer. 0.18. What is the ratio of the Aid flow (current US$) in Mozambique in 1995 to that in 1996?
Offer a very short reply. 0.77. What is the ratio of the Aid flow (current US$) of Sao Tome and Principe in 1995 to that in 1996?
Your response must be concise. 1.65. What is the ratio of the Aid flow (current US$) of Congo (Republic) in 1995 to that in 1998?
Provide a succinct answer. 0.07. What is the ratio of the Aid flow (current US$) of Equatorial Guinea in 1995 to that in 1998?
Give a very brief answer. 0.53. What is the ratio of the Aid flow (current US$) in Mozambique in 1995 to that in 1998?
Keep it short and to the point. 0.24. What is the ratio of the Aid flow (current US$) of Congo (Republic) in 1995 to that in 1999?
Your response must be concise. 0. What is the ratio of the Aid flow (current US$) of Equatorial Guinea in 1995 to that in 1999?
Ensure brevity in your answer.  0.53. What is the ratio of the Aid flow (current US$) in Mozambique in 1995 to that in 1999?
Offer a terse response. 2.33. What is the ratio of the Aid flow (current US$) in Sao Tome and Principe in 1995 to that in 1999?
Provide a succinct answer. 4.27. What is the ratio of the Aid flow (current US$) of Congo (Republic) in 1996 to that in 1998?
Your answer should be compact. 13.77. What is the ratio of the Aid flow (current US$) in Equatorial Guinea in 1996 to that in 1998?
Ensure brevity in your answer.  2.97. What is the ratio of the Aid flow (current US$) in Mozambique in 1996 to that in 1998?
Keep it short and to the point. 0.31. What is the ratio of the Aid flow (current US$) of Congo (Republic) in 1996 to that in 1999?
Give a very brief answer. 0.58. What is the ratio of the Aid flow (current US$) in Equatorial Guinea in 1996 to that in 1999?
Give a very brief answer. 2.97. What is the ratio of the Aid flow (current US$) of Mozambique in 1996 to that in 1999?
Your answer should be very brief. 3.01. What is the ratio of the Aid flow (current US$) in Sao Tome and Principe in 1996 to that in 1999?
Your answer should be compact. 2.59. What is the ratio of the Aid flow (current US$) in Congo (Republic) in 1998 to that in 1999?
Offer a terse response. 0.04. What is the ratio of the Aid flow (current US$) in Equatorial Guinea in 1998 to that in 1999?
Your answer should be very brief. 1. What is the ratio of the Aid flow (current US$) of Mozambique in 1998 to that in 1999?
Keep it short and to the point. 9.56. What is the ratio of the Aid flow (current US$) in Sao Tome and Principe in 1998 to that in 1999?
Provide a succinct answer. 0.09. What is the difference between the highest and the second highest Aid flow (current US$) of Congo (Republic)?
Make the answer very short. 3.43e+07. What is the difference between the highest and the second highest Aid flow (current US$) in Equatorial Guinea?
Offer a terse response. 2.05e+06. What is the difference between the highest and the second highest Aid flow (current US$) in Mozambique?
Provide a succinct answer. 1.39e+08. What is the difference between the highest and the second highest Aid flow (current US$) of Sao Tome and Principe?
Make the answer very short. 9.50e+05. What is the difference between the highest and the lowest Aid flow (current US$) of Congo (Republic)?
Your answer should be very brief. 8.17e+07. What is the difference between the highest and the lowest Aid flow (current US$) of Equatorial Guinea?
Provide a short and direct response. 3.23e+06. What is the difference between the highest and the lowest Aid flow (current US$) in Mozambique?
Provide a short and direct response. 2.38e+08. What is the difference between the highest and the lowest Aid flow (current US$) in Sao Tome and Principe?
Provide a short and direct response. 1.88e+06. 